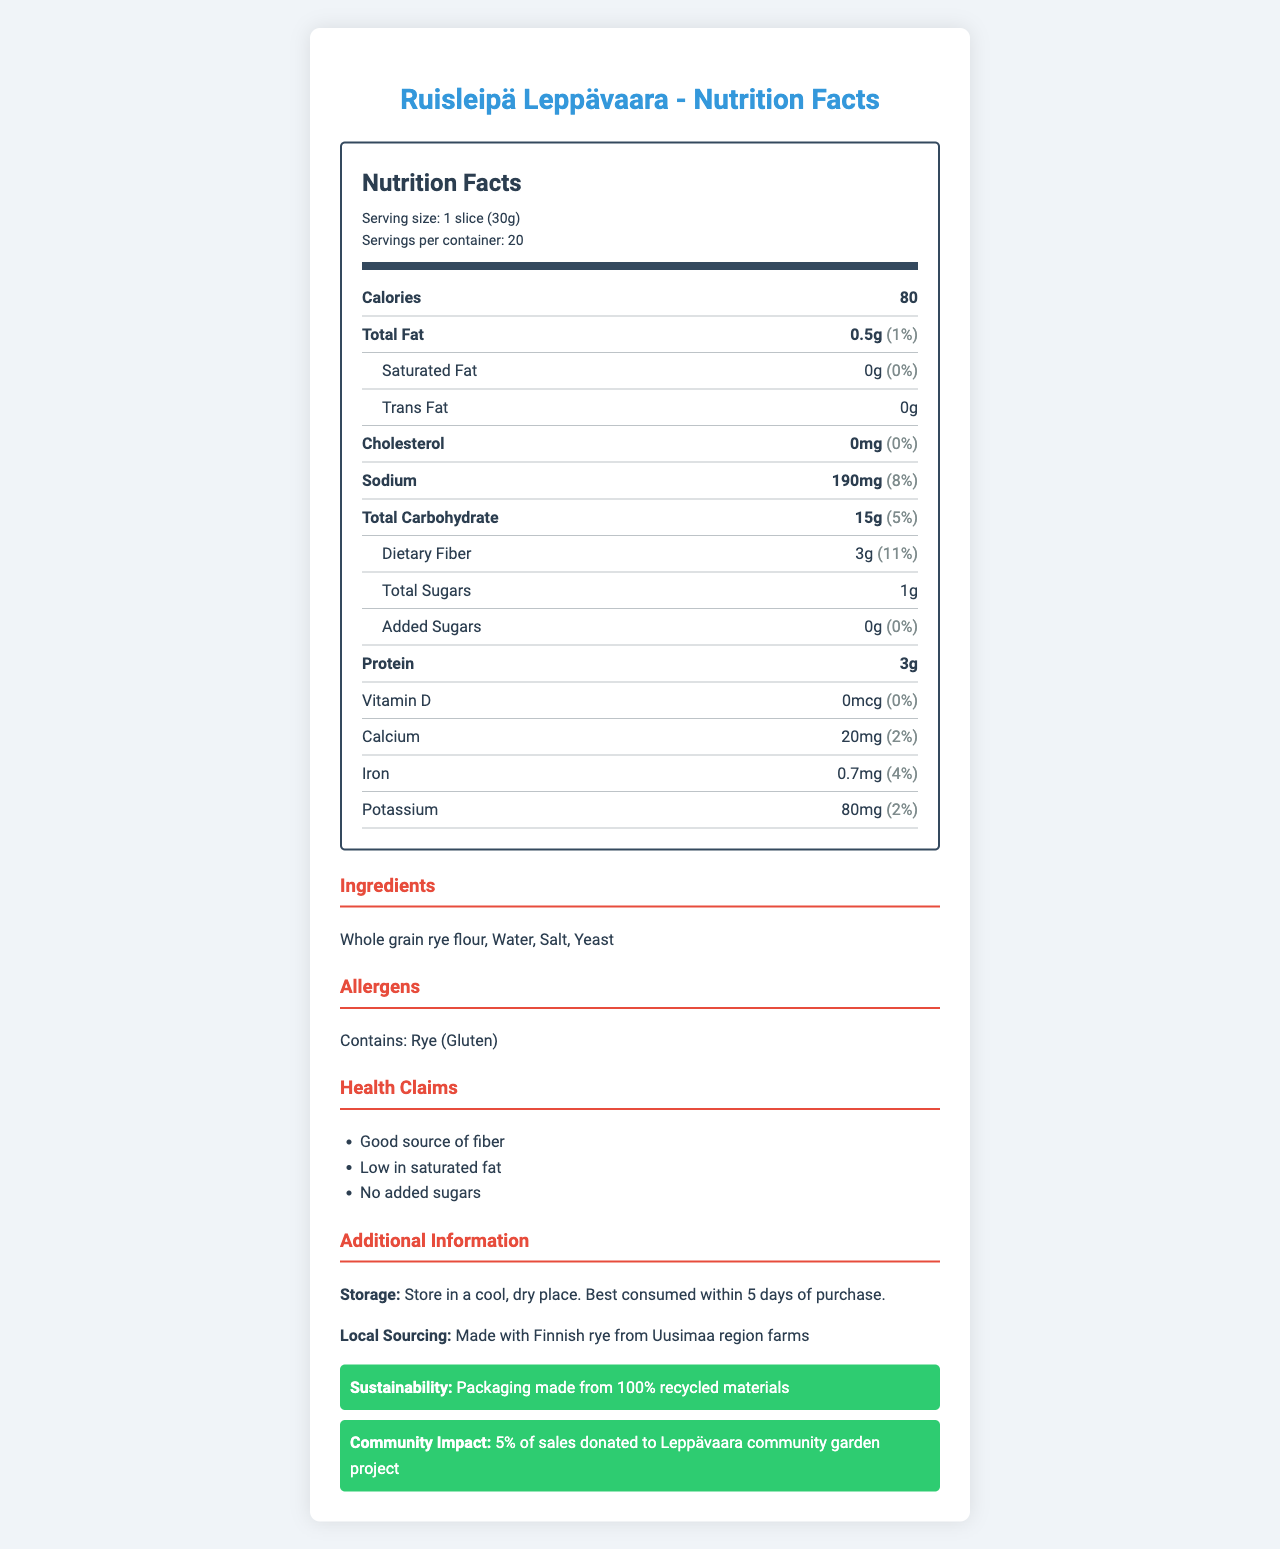what is the serving size for Ruisleipä Leppävaara? The document clearly states that the serving size for Ruisleipä Leppävaara is 1 slice (30g) under the nutrition header section.
Answer: 1 slice (30g) how many calories are in one serving of Ruisleipä Leppävaara? The number of calories per serving is listed as 80 in the nutrition item section.
Answer: 80 what are the main ingredients in Ruisleipä Leppävaara? The main ingredients are listed under the "Ingredients" section as Whole Grain rye flour, Water, Salt, and Yeast.
Answer: Whole grain rye flour, Water, Salt, Yeast what percentage of the daily value of iron does one slice of Ruisleipä Leppävaara provide? The daily value percentage for iron is given as 4% in the nutritional information section.
Answer: 4% how much dietary fiber does one slice of Ruisleipä Leppävaara contain? The amount of dietary fiber per serving is listed as 3g in the sub-item nutritional information section for dietary fiber.
Answer: 3g how many servings are there in one container of Ruisleipä Leppävaara? A. 10 B. 15 C. 20 D. 25 According to the nutrition facts, there are 20 servings per container as mentioned in the serving info section.
Answer: C. 20 which of the following is a health claim made on the packaging of Ruisleipä Leppävaara? i. Good source of protein ii. Low in saturated fat iii. High in sugar A. i only B. ii only C. i and ii D. ii and iii The health claims listed include "Good source of fiber," "Low in saturated fat," and "No added sugars." Only ii is correct among the given options.
Answer: B. ii only is Ruisleipä Leppävaara suitable for people with a gluten allergy? The allergens section states that it contains rye, which includes gluten, making it unsuitable for individuals with a gluten allergy.
Answer: No summarize the nutritional and additional information provided about Ruisleipä Leppävaara. This summary covers the nutritional aspects like calories, fat, fiber, and sugars, as well as details on ingredients, allergens, health claims, and additional community and sustainability information provided in the document.
Answer: Ruisleipä Leppävaara is a type of Finnish rye bread made by Leppävaaran Leipomo. It is low in calories (80 per slice) and fat (0.5g total fat), with significant dietary fiber (3g), and no added sugars. The bread contains essential minerals like calcium and iron in small amounts. It is made from whole grain rye flour, water, salt, and yeast, and contains gluten. The product emphasizes its health benefits, being a good source of fiber and low in saturated fat. It also supports sustainability through recycled packaging and contributes to the local community by donating a portion of sales to a community garden project. how much protein is in one slice of Ruisleipä Leppävaara? The protein content per serving is listed as 3g in the nutrition item section.
Answer: 3g is there any added sugar in Ruisleipä Leppävaara? The nutritional information specifies that there are 0g of added sugars in the bread.
Answer: No does Ruisleipä Leppävaara contain any trans fat? The label states that there is 0g trans fat per serving.
Answer: No how long is Ruisleipä Leppävaara best consumed after purchase as stated in the storage instructions? The storage instructions section suggests that the bread is best consumed within 5 days of purchase.
Answer: Best consumed within 5 days of purchase where is the rye used in Ruisleipä Leppävaara sourced from? The local sourcing section specifies that the rye is sourced from Uusimaa region farms.
Answer: Uusimaa region farms in Finland what is the percentage of daily value for sodium in one slice of Ruisleipä Leppävaara? The daily value percentage for sodium is 8% as listed in the nutrition item section.
Answer: 8% 